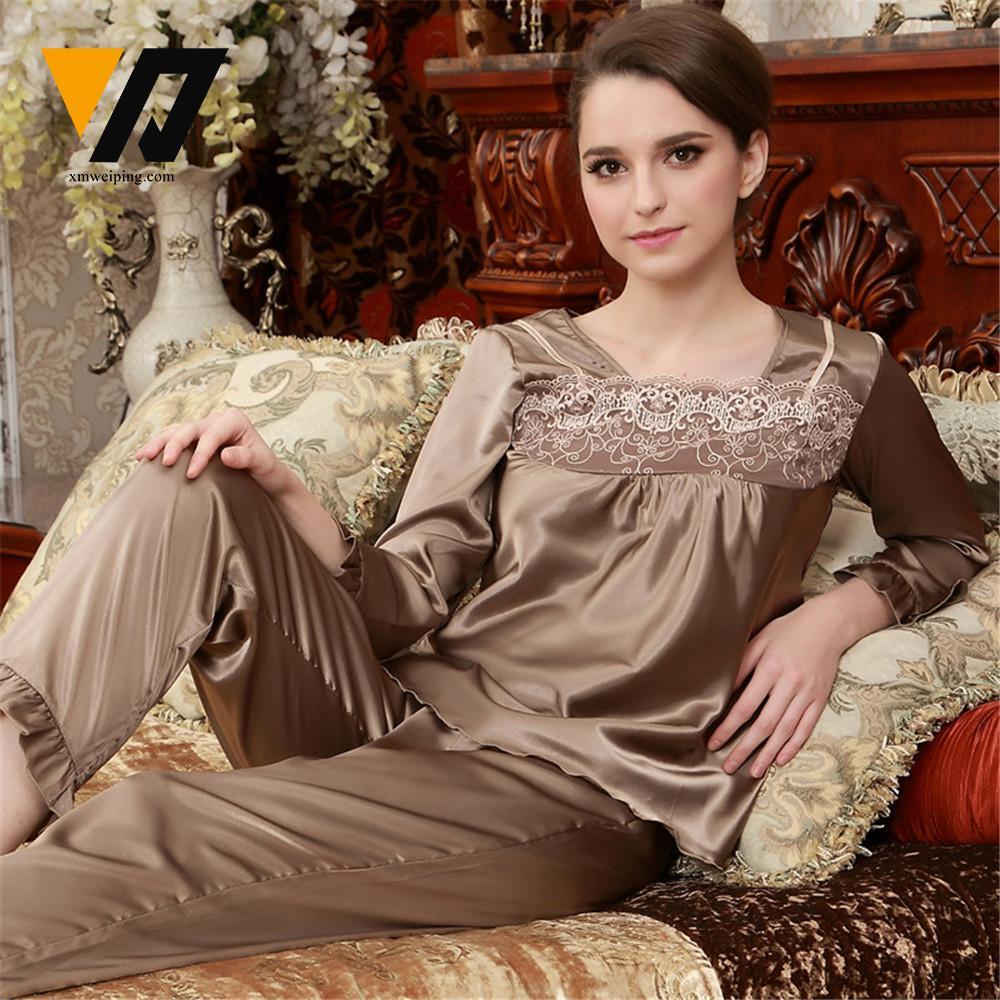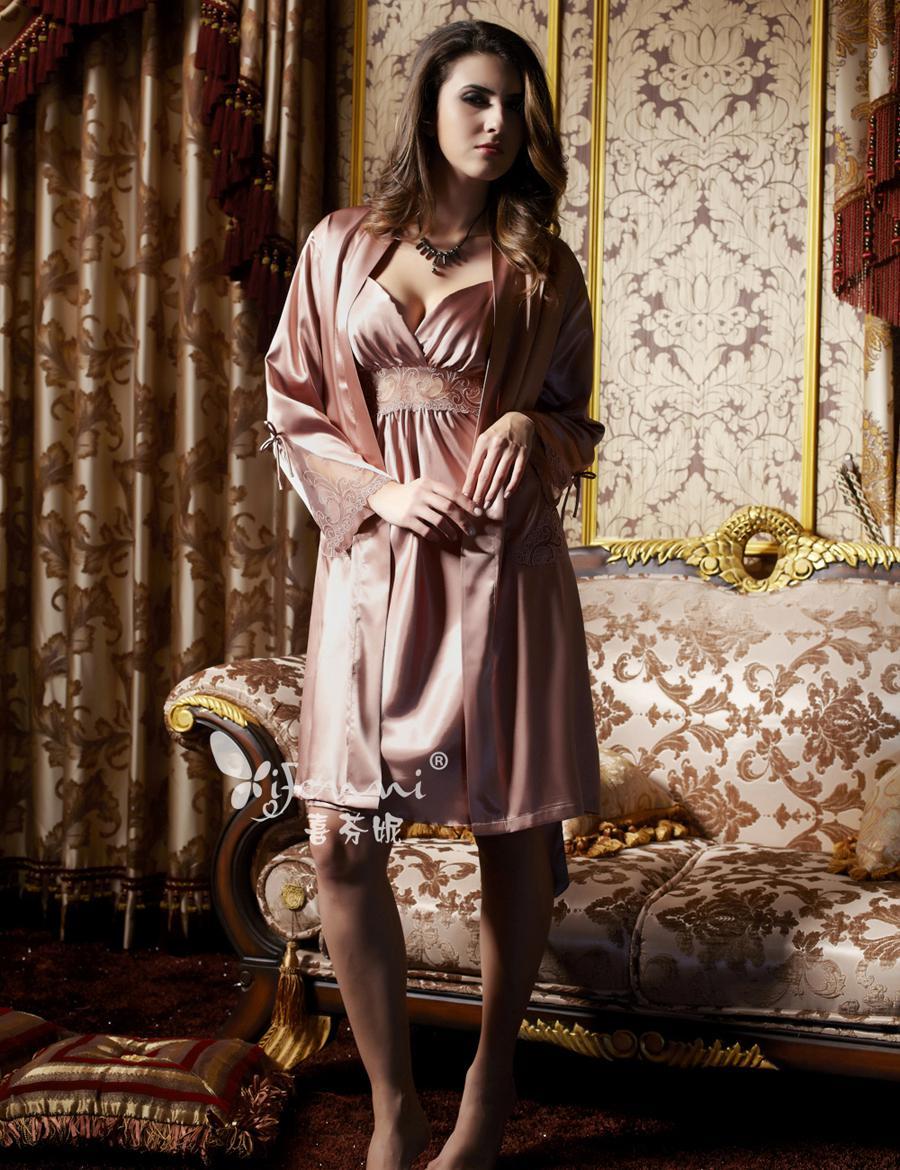The first image is the image on the left, the second image is the image on the right. Given the left and right images, does the statement "A man and woman in pajamas pose near a sofa in one of the images." hold true? Answer yes or no. No. The first image is the image on the left, the second image is the image on the right. Evaluate the accuracy of this statement regarding the images: "An image shows a man to the right of a woman, and both are modeling shiny loungewear.". Is it true? Answer yes or no. No. 